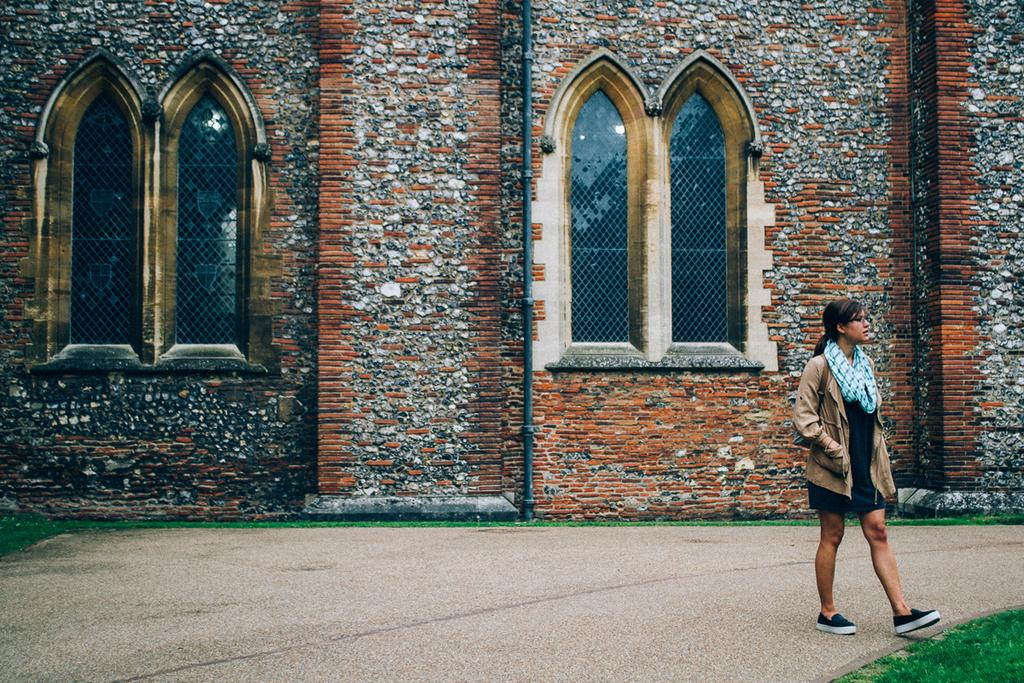What is the woman in the image doing? The woman is walking on the platform in the image. What can be seen in the background of the image? There is a building, windows, and a pole on the wall visible in the background of the image. What type of surface is the woman walking on? The woman is walking on a platform. What is present on the ground in the image? Grass is present on the ground in the image. What type of fuel is the woman using to walk in the image? The woman is not using any fuel to walk in the image; she is walking on her own. 